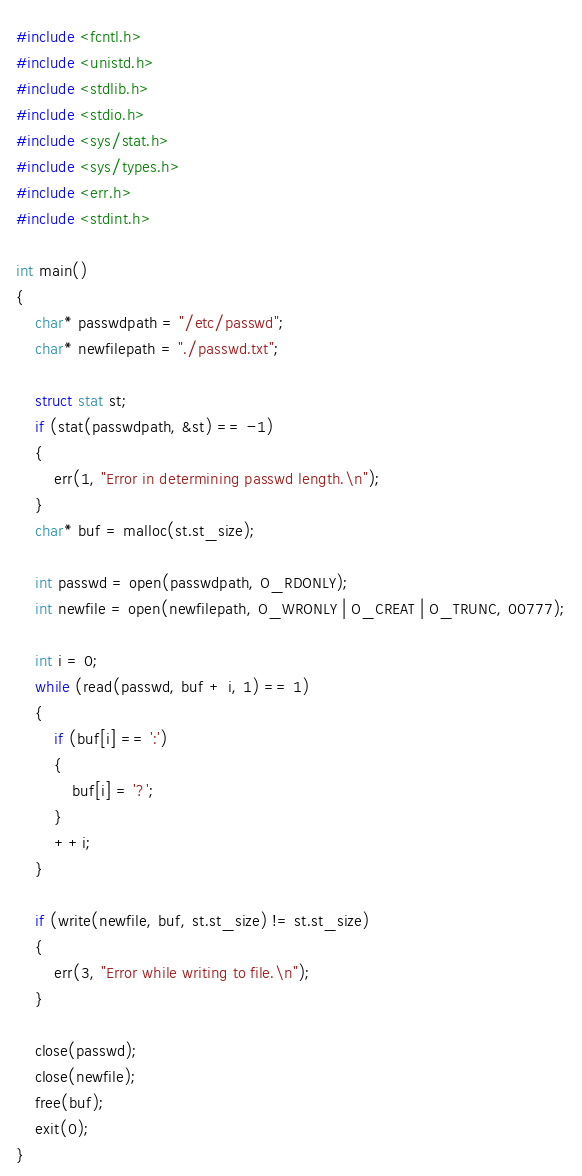Convert code to text. <code><loc_0><loc_0><loc_500><loc_500><_C_>#include <fcntl.h>
#include <unistd.h>
#include <stdlib.h>
#include <stdio.h>
#include <sys/stat.h>
#include <sys/types.h>
#include <err.h>
#include <stdint.h>

int main()
{
	char* passwdpath = "/etc/passwd";
	char* newfilepath = "./passwd.txt";

	struct stat st;
	if (stat(passwdpath, &st) == -1)
	{
		err(1, "Error in determining passwd length.\n");
	}
	char* buf = malloc(st.st_size);

	int passwd = open(passwdpath, O_RDONLY);
	int newfile = open(newfilepath, O_WRONLY | O_CREAT | O_TRUNC, 00777);

	int i = 0;
	while (read(passwd, buf + i, 1) == 1)
	{
		if (buf[i] == ':')
		{
			buf[i] = '?';
		}
		++i;
	}

	if (write(newfile, buf, st.st_size) != st.st_size)
	{
		err(3, "Error while writing to file.\n");
	}

	close(passwd);
	close(newfile);
	free(buf);
	exit(0);
}
</code> 